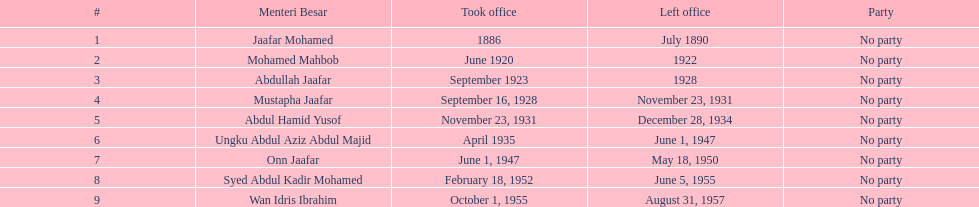Write the full table. {'header': ['#', 'Menteri Besar', 'Took office', 'Left office', 'Party'], 'rows': [['1', 'Jaafar Mohamed', '1886', 'July 1890', 'No party'], ['2', 'Mohamed Mahbob', 'June 1920', '1922', 'No party'], ['3', 'Abdullah Jaafar', 'September 1923', '1928', 'No party'], ['4', 'Mustapha Jaafar', 'September 16, 1928', 'November 23, 1931', 'No party'], ['5', 'Abdul Hamid Yusof', 'November 23, 1931', 'December 28, 1934', 'No party'], ['6', 'Ungku Abdul Aziz Abdul Majid', 'April 1935', 'June 1, 1947', 'No party'], ['7', 'Onn Jaafar', 'June 1, 1947', 'May 18, 1950', 'No party'], ['8', 'Syed Abdul Kadir Mohamed', 'February 18, 1952', 'June 5, 1955', 'No party'], ['9', 'Wan Idris Ibrahim', 'October 1, 1955', 'August 31, 1957', 'No party']]} How many menteri besar have had a tenure of 4 or more years? 3. 